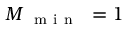Convert formula to latex. <formula><loc_0><loc_0><loc_500><loc_500>M _ { \mathrm { m i n } } = 1</formula> 